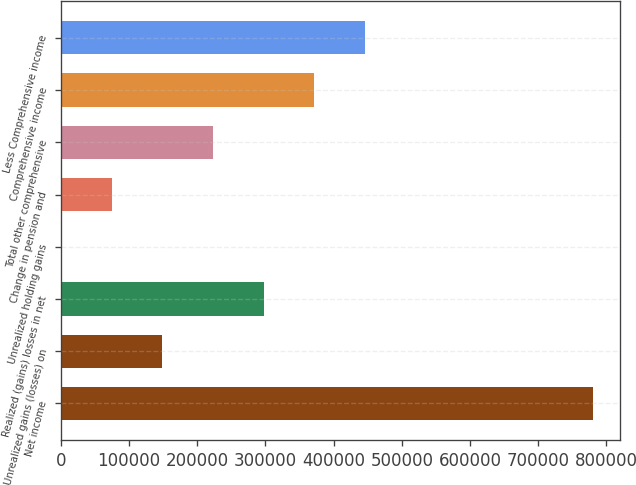Convert chart. <chart><loc_0><loc_0><loc_500><loc_500><bar_chart><fcel>Net income<fcel>Unrealized gains (losses) on<fcel>Realized (gains) losses in net<fcel>Unrealized holding gains<fcel>Change in pension and<fcel>Total other comprehensive<fcel>Comprehensive income<fcel>Less Comprehensive income<nl><fcel>780191<fcel>148744<fcel>297440<fcel>47<fcel>74395.3<fcel>223092<fcel>371788<fcel>446137<nl></chart> 